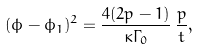Convert formula to latex. <formula><loc_0><loc_0><loc_500><loc_500>( \phi - \phi _ { 1 } ) ^ { 2 } = \frac { 4 ( 2 p - 1 ) } { \kappa \Gamma _ { 0 } } \, \frac { p } { t } ,</formula> 